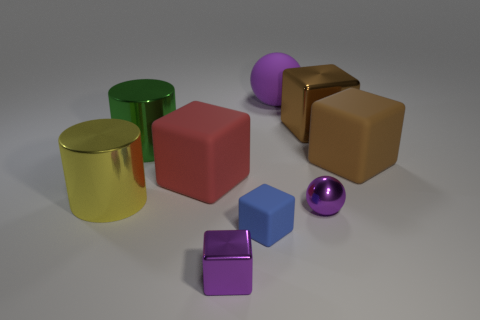The other thing that is the same shape as the large yellow thing is what size?
Provide a short and direct response. Large. Are any large brown metallic cubes visible?
Your answer should be compact. Yes. How many things are either purple things that are behind the metallic ball or small cyan matte cylinders?
Ensure brevity in your answer.  1. There is a ball that is the same size as the blue matte object; what is it made of?
Give a very brief answer. Metal. There is a large object on the left side of the metal cylinder on the right side of the big yellow shiny cylinder; what color is it?
Provide a succinct answer. Yellow. There is a big red matte thing; how many big cylinders are to the left of it?
Keep it short and to the point. 2. The shiny ball is what color?
Your answer should be very brief. Purple. How many large objects are brown rubber cylinders or red blocks?
Keep it short and to the point. 1. There is a big matte object left of the purple rubber sphere; is its color the same as the large shiny object on the right side of the green metallic object?
Your answer should be very brief. No. What number of other objects are the same color as the small rubber block?
Make the answer very short. 0. 